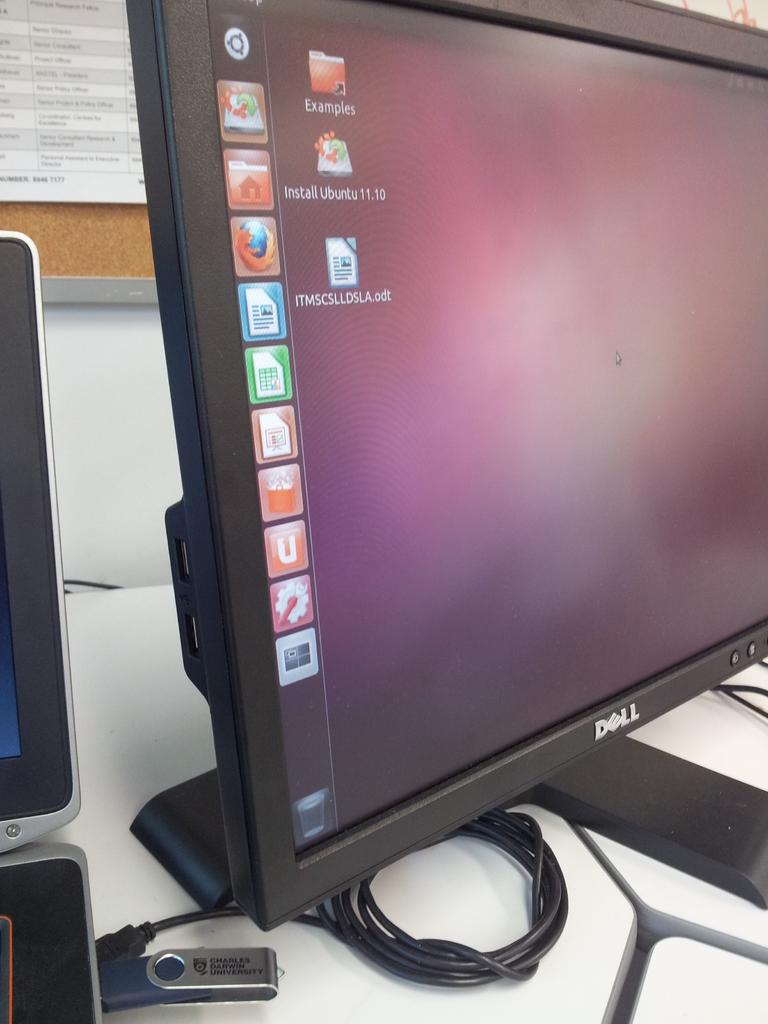What electronic device is present in the image? There is a monitor in the image. What is connected to the monitor? A pen drive is connected to the monitor. How is the pen drive connected to the monitor? There is a wire connected to the pen drive. What can be seen on the board in the image? There are papers on the board. What is visible behind the board in the image? There is a wall visible in the image. How many trains are visible on the board in the image? There are no trains visible on the board or in the image. What type of credit is being discussed on the papers on the board? There is no mention of credit or any financial topic on the papers on the board or in the image. 